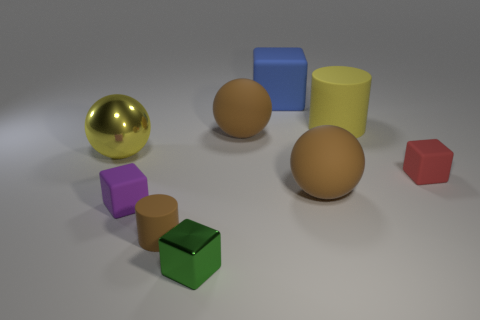Is the color of the large cylinder the same as the large metal object?
Offer a terse response. Yes. There is a rubber sphere that is on the left side of the large blue cube; is its color the same as the cylinder that is left of the green shiny thing?
Ensure brevity in your answer.  Yes. There is a big thing that is the same color as the large matte cylinder; what is it made of?
Your answer should be compact. Metal. There is a big sphere in front of the sphere on the left side of the purple rubber object; is there a rubber thing in front of it?
Provide a succinct answer. Yes. What number of other objects are there of the same color as the small cylinder?
Give a very brief answer. 2. There is a brown matte cylinder that is in front of the red rubber thing; does it have the same size as the brown rubber ball in front of the large yellow sphere?
Offer a terse response. No. Is the number of tiny cylinders that are behind the big yellow cylinder the same as the number of small cubes on the right side of the small green cube?
Keep it short and to the point. No. Is the size of the yellow metallic sphere the same as the cylinder that is left of the green block?
Provide a succinct answer. No. What is the material of the cube that is on the right side of the big brown ball that is in front of the tiny red rubber object?
Keep it short and to the point. Rubber. Is the number of big yellow cylinders that are to the left of the big rubber cylinder the same as the number of tiny purple cylinders?
Offer a terse response. Yes. 